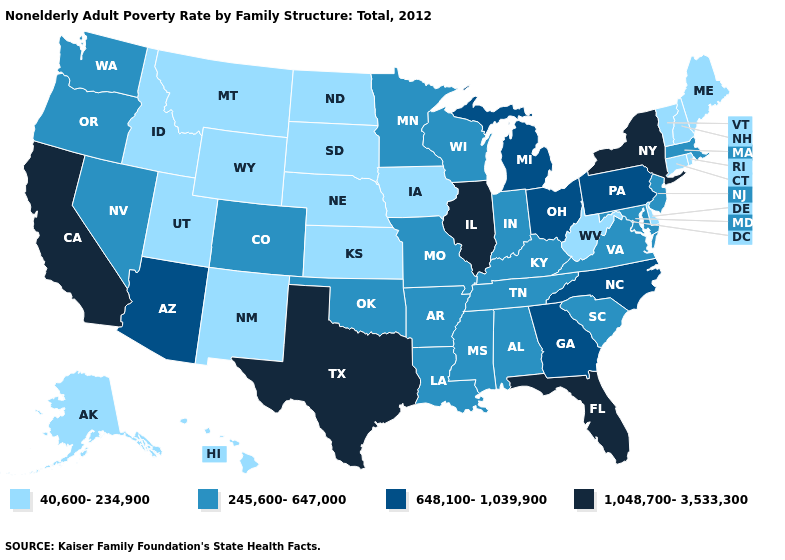Is the legend a continuous bar?
Give a very brief answer. No. Does the map have missing data?
Keep it brief. No. Does Virginia have a higher value than Maine?
Concise answer only. Yes. Name the states that have a value in the range 1,048,700-3,533,300?
Answer briefly. California, Florida, Illinois, New York, Texas. Name the states that have a value in the range 648,100-1,039,900?
Give a very brief answer. Arizona, Georgia, Michigan, North Carolina, Ohio, Pennsylvania. What is the lowest value in the Northeast?
Quick response, please. 40,600-234,900. What is the lowest value in the West?
Answer briefly. 40,600-234,900. Name the states that have a value in the range 245,600-647,000?
Answer briefly. Alabama, Arkansas, Colorado, Indiana, Kentucky, Louisiana, Maryland, Massachusetts, Minnesota, Mississippi, Missouri, Nevada, New Jersey, Oklahoma, Oregon, South Carolina, Tennessee, Virginia, Washington, Wisconsin. What is the highest value in states that border Delaware?
Give a very brief answer. 648,100-1,039,900. Does the first symbol in the legend represent the smallest category?
Quick response, please. Yes. What is the lowest value in the USA?
Write a very short answer. 40,600-234,900. Name the states that have a value in the range 245,600-647,000?
Concise answer only. Alabama, Arkansas, Colorado, Indiana, Kentucky, Louisiana, Maryland, Massachusetts, Minnesota, Mississippi, Missouri, Nevada, New Jersey, Oklahoma, Oregon, South Carolina, Tennessee, Virginia, Washington, Wisconsin. Is the legend a continuous bar?
Answer briefly. No. Does the map have missing data?
Write a very short answer. No. 